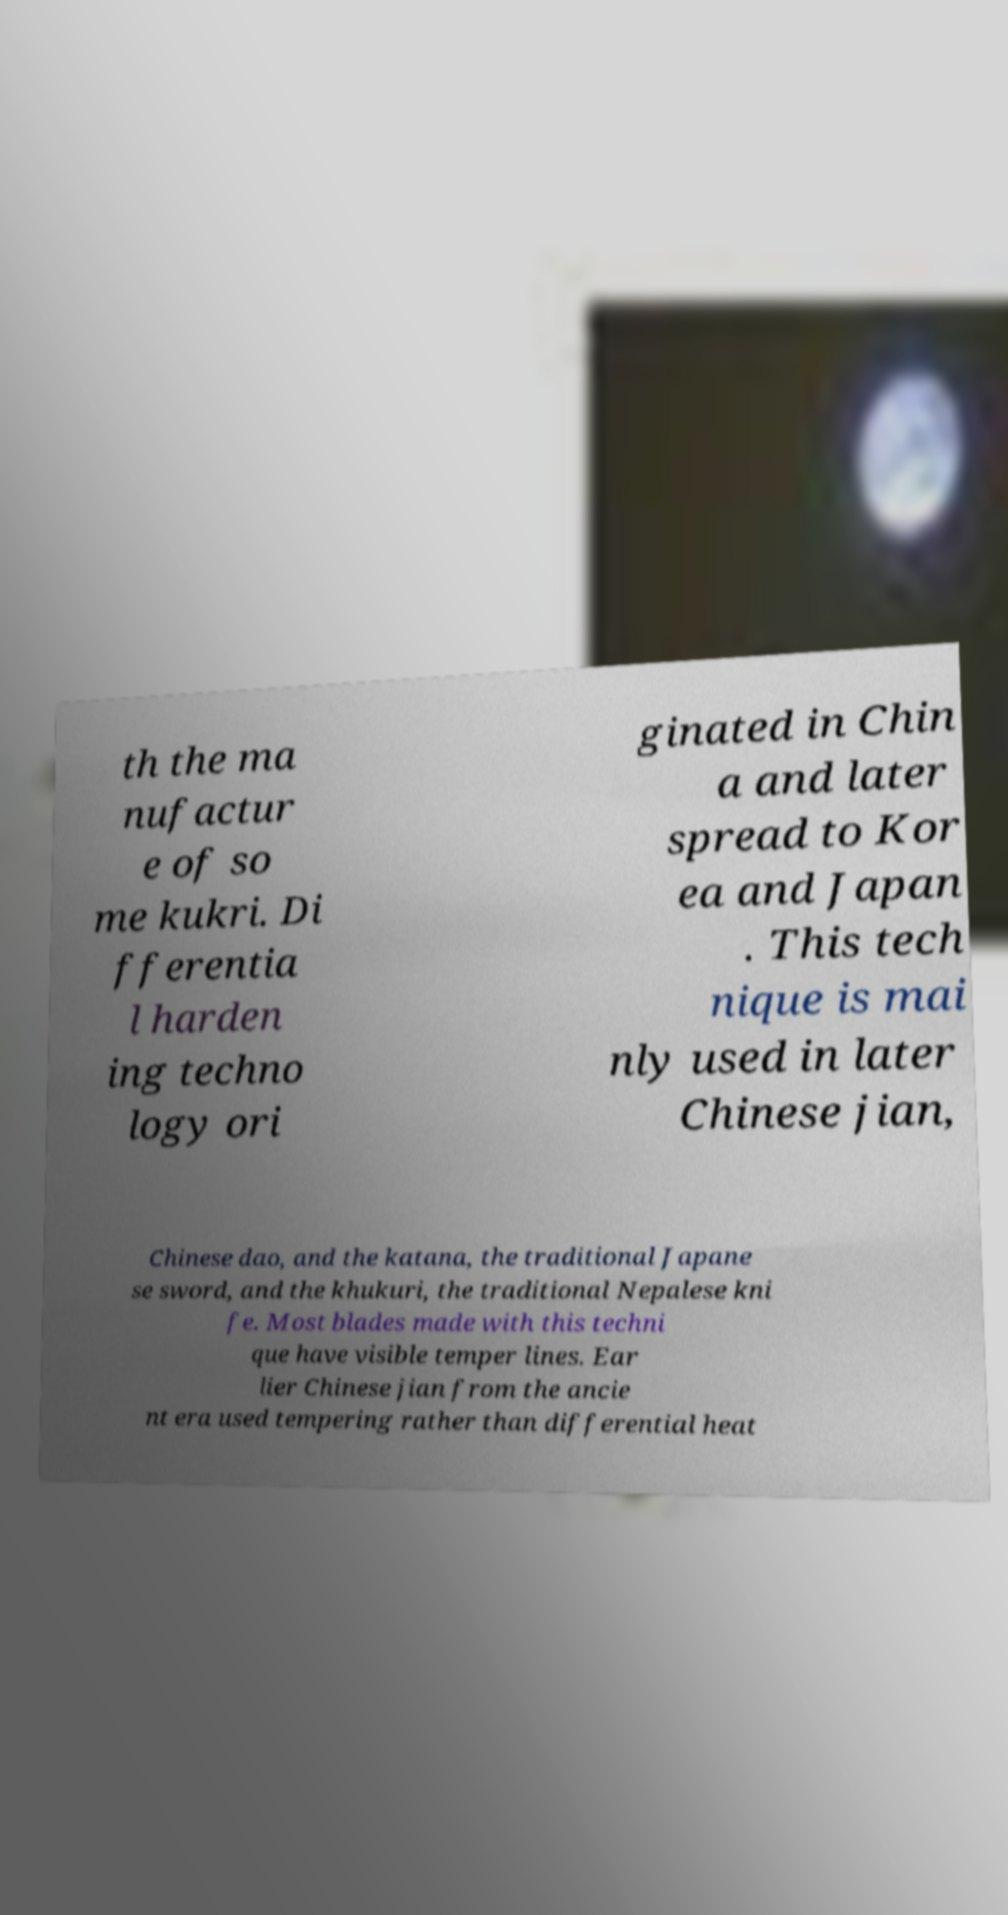Please identify and transcribe the text found in this image. th the ma nufactur e of so me kukri. Di fferentia l harden ing techno logy ori ginated in Chin a and later spread to Kor ea and Japan . This tech nique is mai nly used in later Chinese jian, Chinese dao, and the katana, the traditional Japane se sword, and the khukuri, the traditional Nepalese kni fe. Most blades made with this techni que have visible temper lines. Ear lier Chinese jian from the ancie nt era used tempering rather than differential heat 